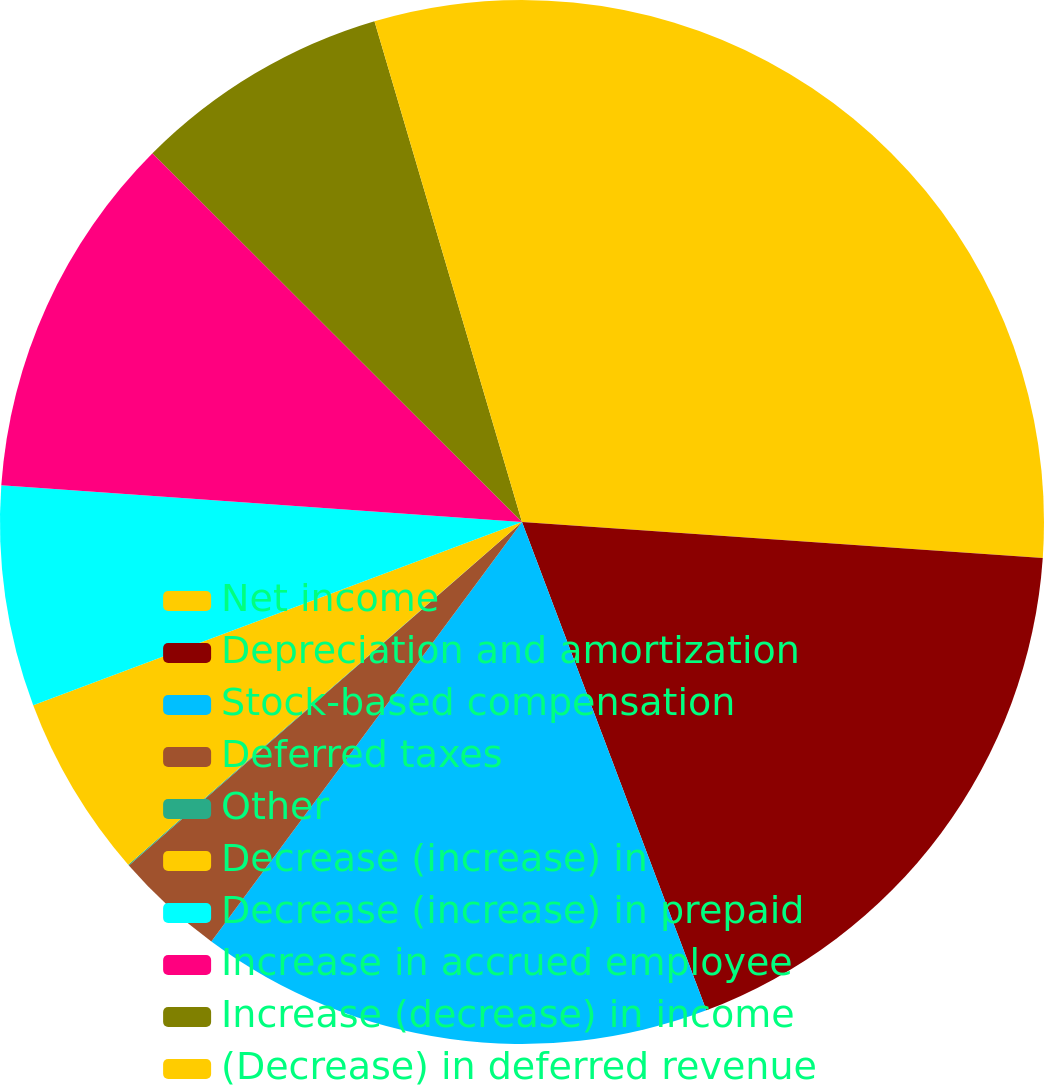<chart> <loc_0><loc_0><loc_500><loc_500><pie_chart><fcel>Net income<fcel>Depreciation and amortization<fcel>Stock-based compensation<fcel>Deferred taxes<fcel>Other<fcel>Decrease (increase) in<fcel>Decrease (increase) in prepaid<fcel>Increase in accrued employee<fcel>Increase (decrease) in income<fcel>(Decrease) in deferred revenue<nl><fcel>26.1%<fcel>18.16%<fcel>15.89%<fcel>3.43%<fcel>0.03%<fcel>5.69%<fcel>6.83%<fcel>11.36%<fcel>7.96%<fcel>4.56%<nl></chart> 